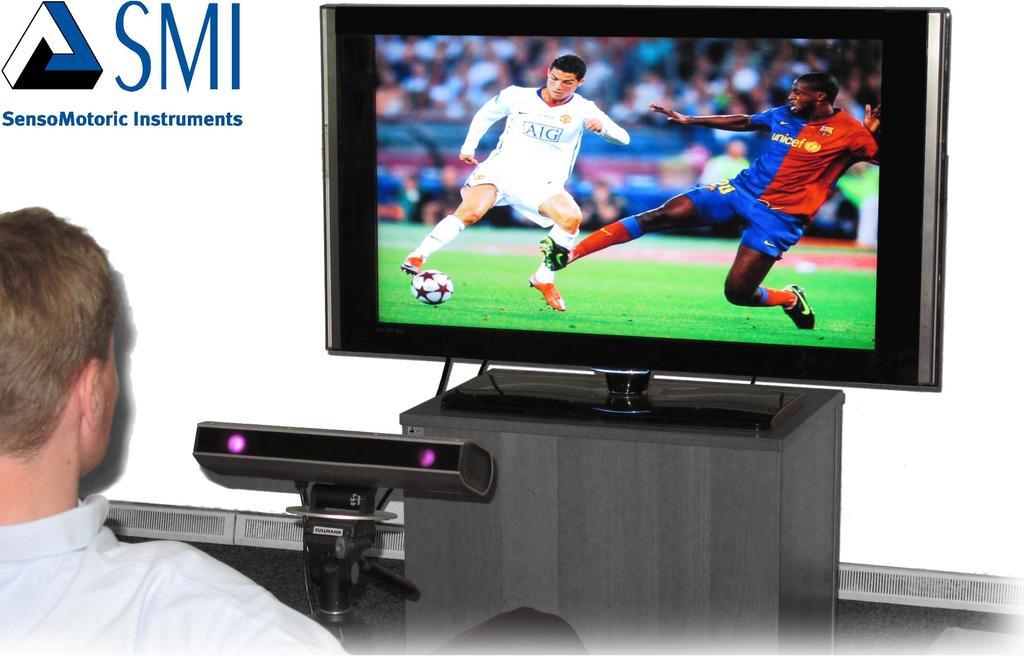What company is shown?
Your response must be concise. Sensomotoric instruments. 